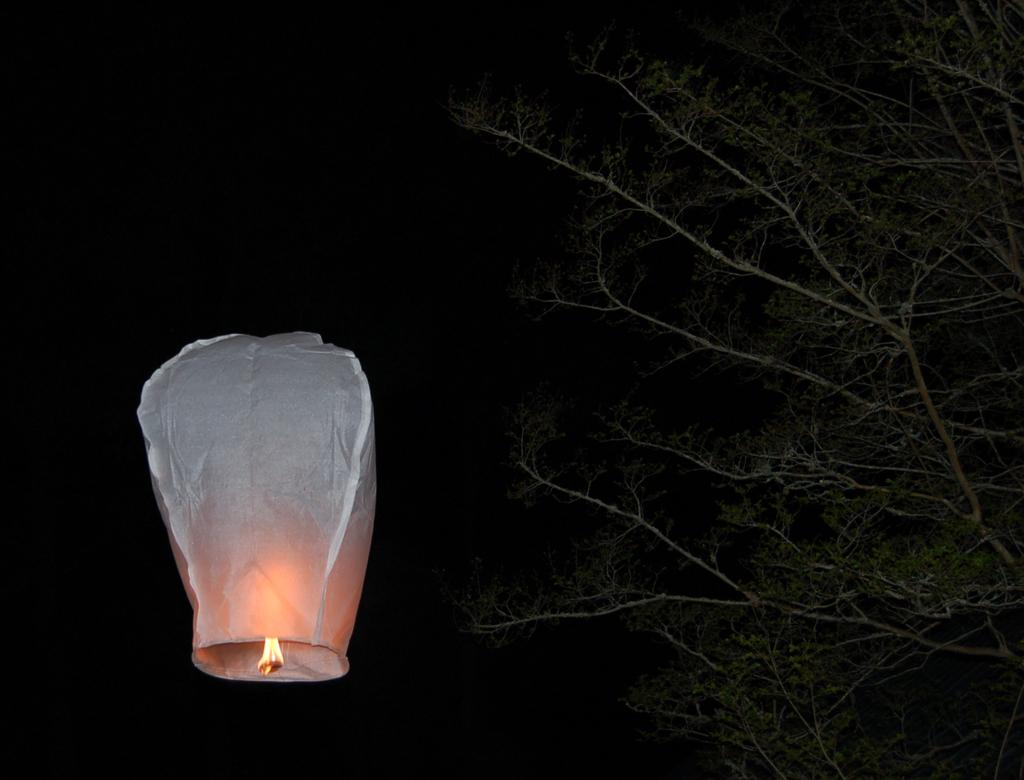What is suspended in the air in the image? There is a lantern in the air in the image. What type of natural environment can be seen in the image? There are trees visible in the image. How would you describe the lighting conditions in the image? The background of the image is dark. What type of furniture is visible in the image? There is no furniture present in the image. Can you tell me how many slaves are depicted in the image? There are no slaves depicted in the image; it does not contain any human figures. 